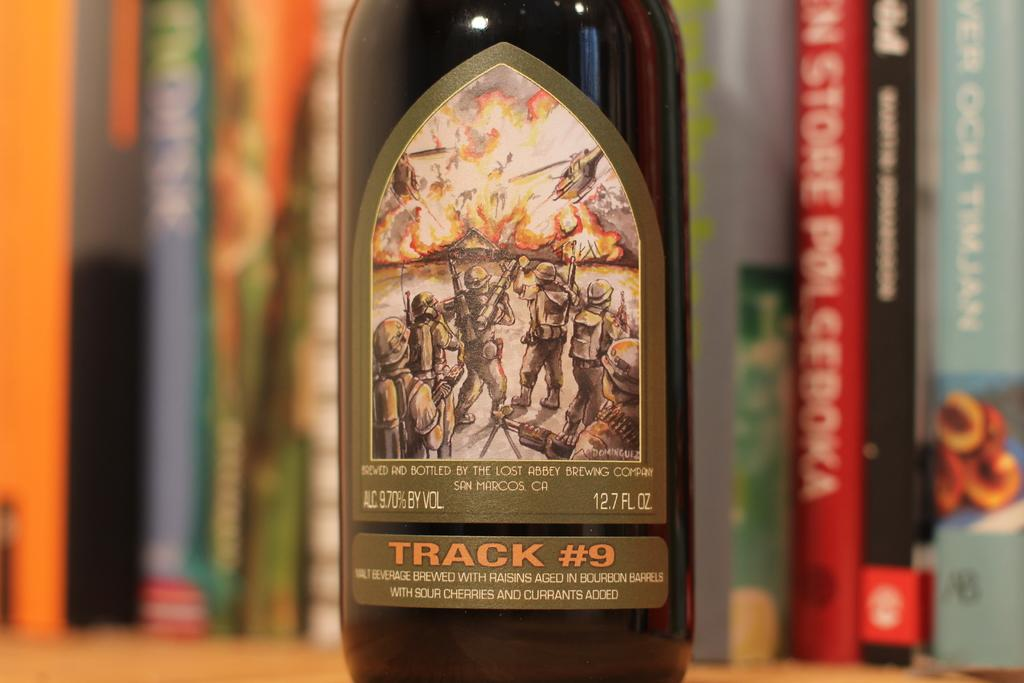<image>
Describe the image concisely. A book shelf with books on it also has a bottle of Track #9 beer on it. 